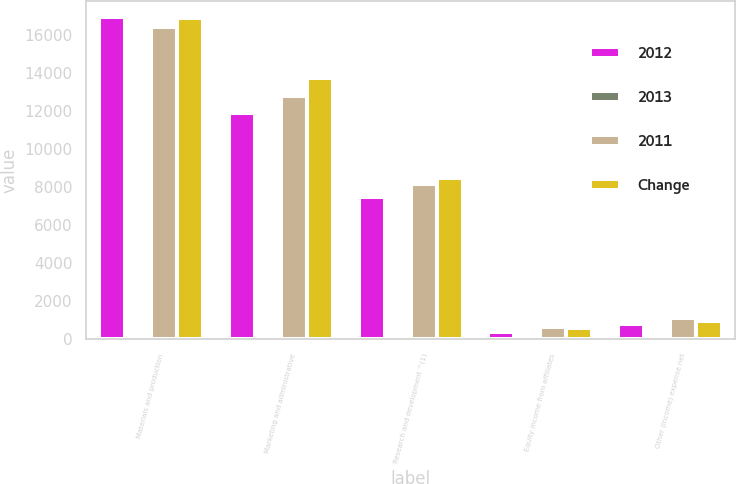Convert chart to OTSL. <chart><loc_0><loc_0><loc_500><loc_500><stacked_bar_chart><ecel><fcel>Materials and production<fcel>Marketing and administrative<fcel>Research and development ^(1)<fcel>Equity income from affiliates<fcel>Other (income) expense net<nl><fcel>2012<fcel>16954<fcel>11911<fcel>7503<fcel>404<fcel>815<nl><fcel>2013<fcel>3<fcel>7<fcel>8<fcel>37<fcel>27<nl><fcel>2011<fcel>16446<fcel>12776<fcel>8168<fcel>642<fcel>1116<nl><fcel>Change<fcel>16871<fcel>13733<fcel>8467<fcel>610<fcel>946<nl></chart> 